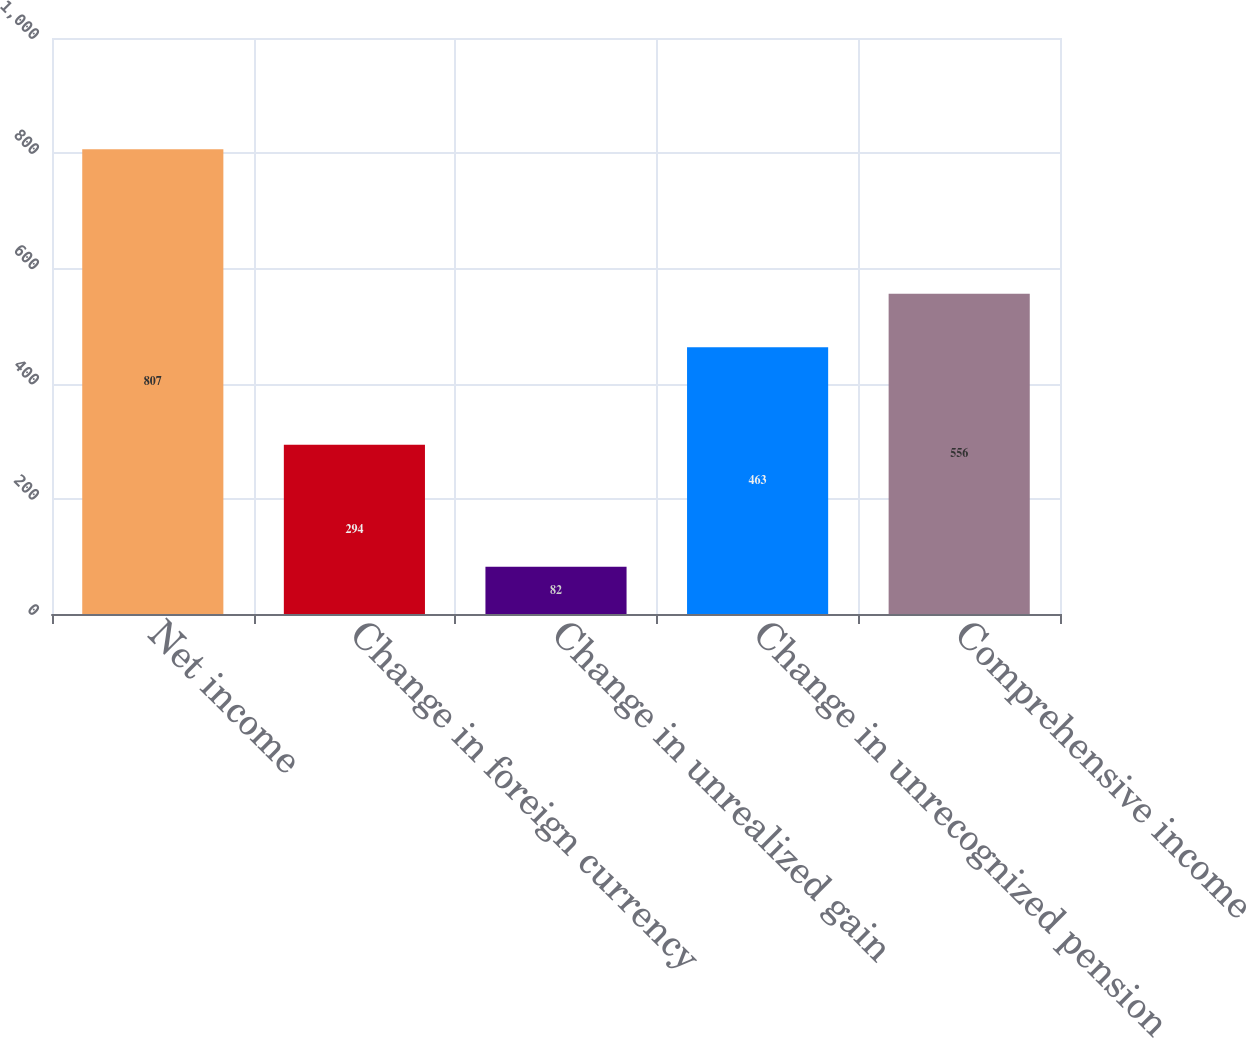Convert chart. <chart><loc_0><loc_0><loc_500><loc_500><bar_chart><fcel>Net income<fcel>Change in foreign currency<fcel>Change in unrealized gain<fcel>Change in unrecognized pension<fcel>Comprehensive income<nl><fcel>807<fcel>294<fcel>82<fcel>463<fcel>556<nl></chart> 